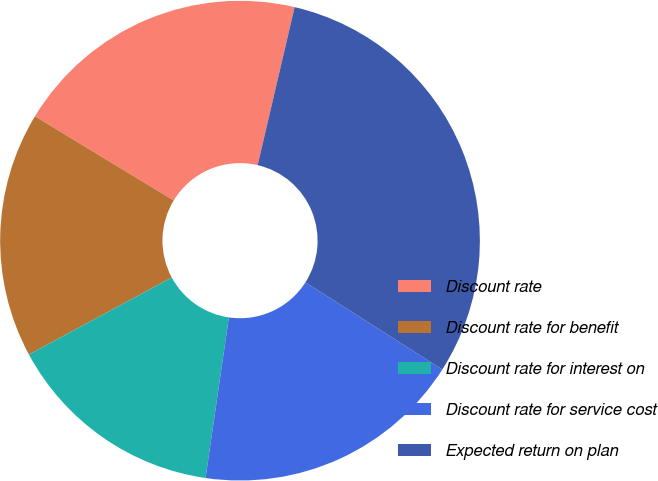Convert chart. <chart><loc_0><loc_0><loc_500><loc_500><pie_chart><fcel>Discount rate<fcel>Discount rate for benefit<fcel>Discount rate for interest on<fcel>Discount rate for service cost<fcel>Expected return on plan<nl><fcel>19.98%<fcel>16.55%<fcel>14.83%<fcel>18.27%<fcel>30.37%<nl></chart> 